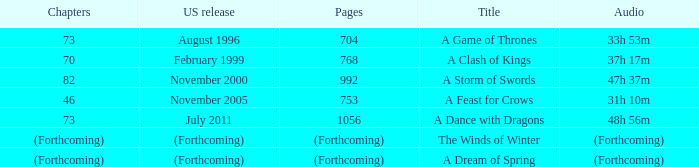Which title has a US release of august 1996? A Game of Thrones. 